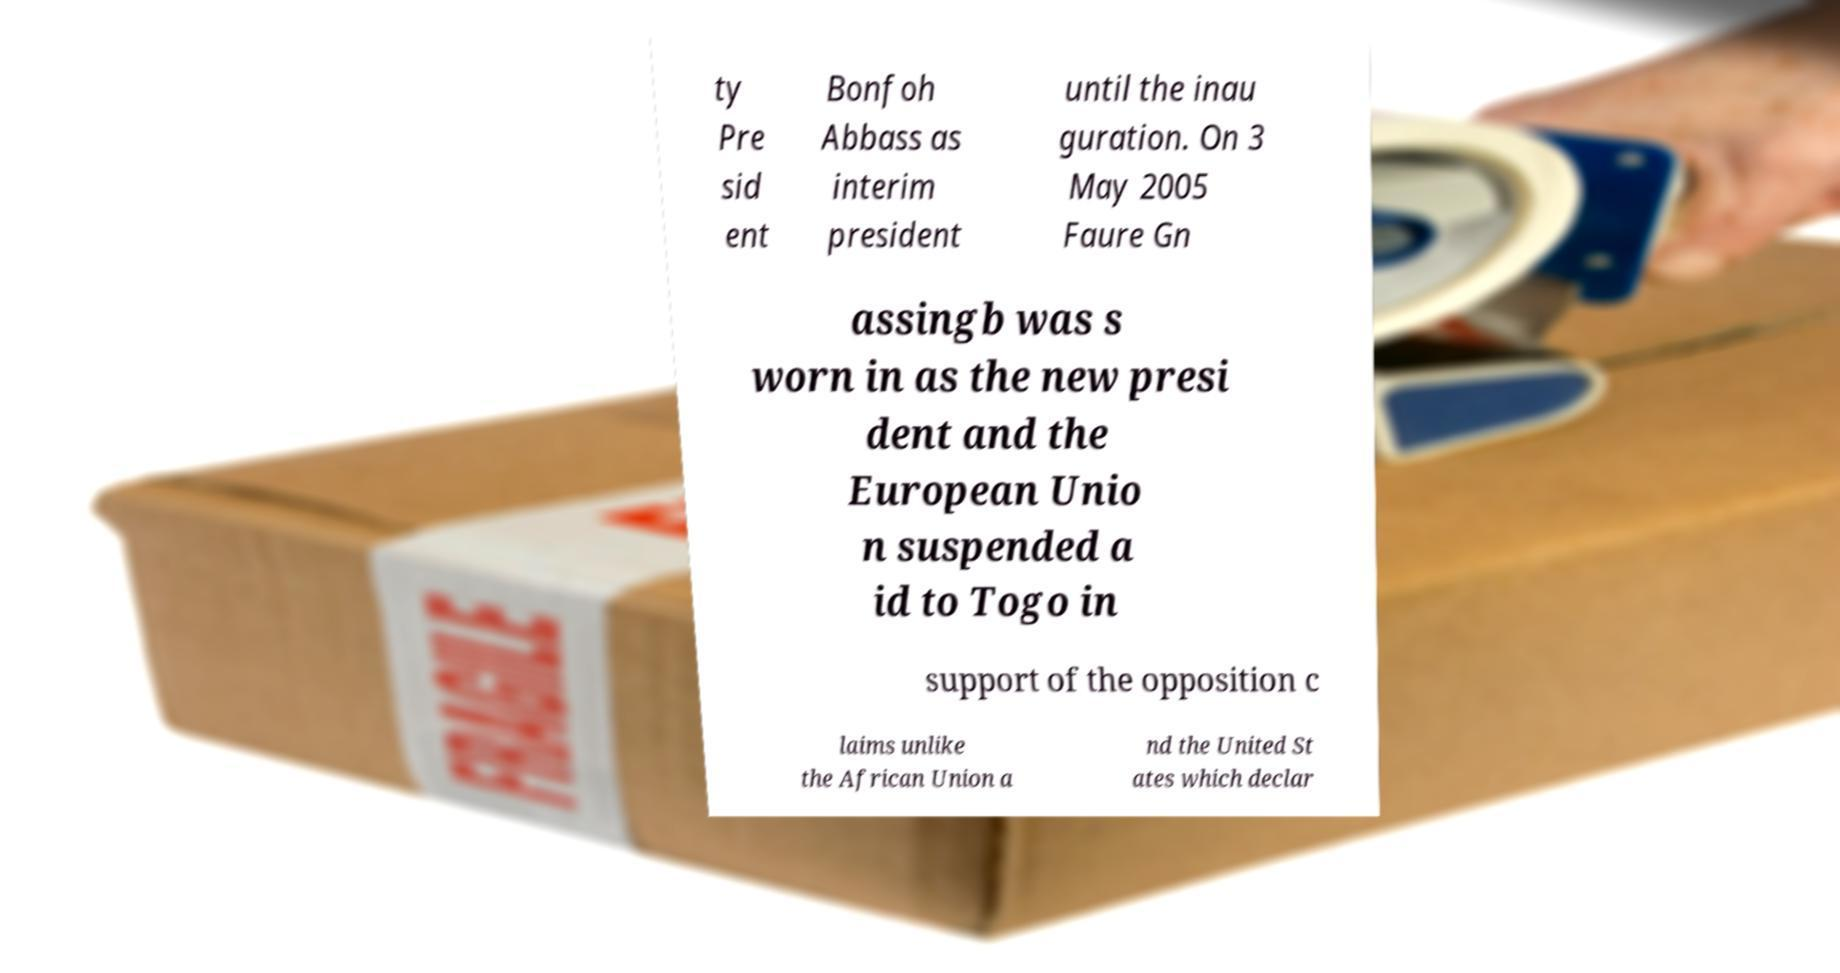Could you extract and type out the text from this image? ty Pre sid ent Bonfoh Abbass as interim president until the inau guration. On 3 May 2005 Faure Gn assingb was s worn in as the new presi dent and the European Unio n suspended a id to Togo in support of the opposition c laims unlike the African Union a nd the United St ates which declar 